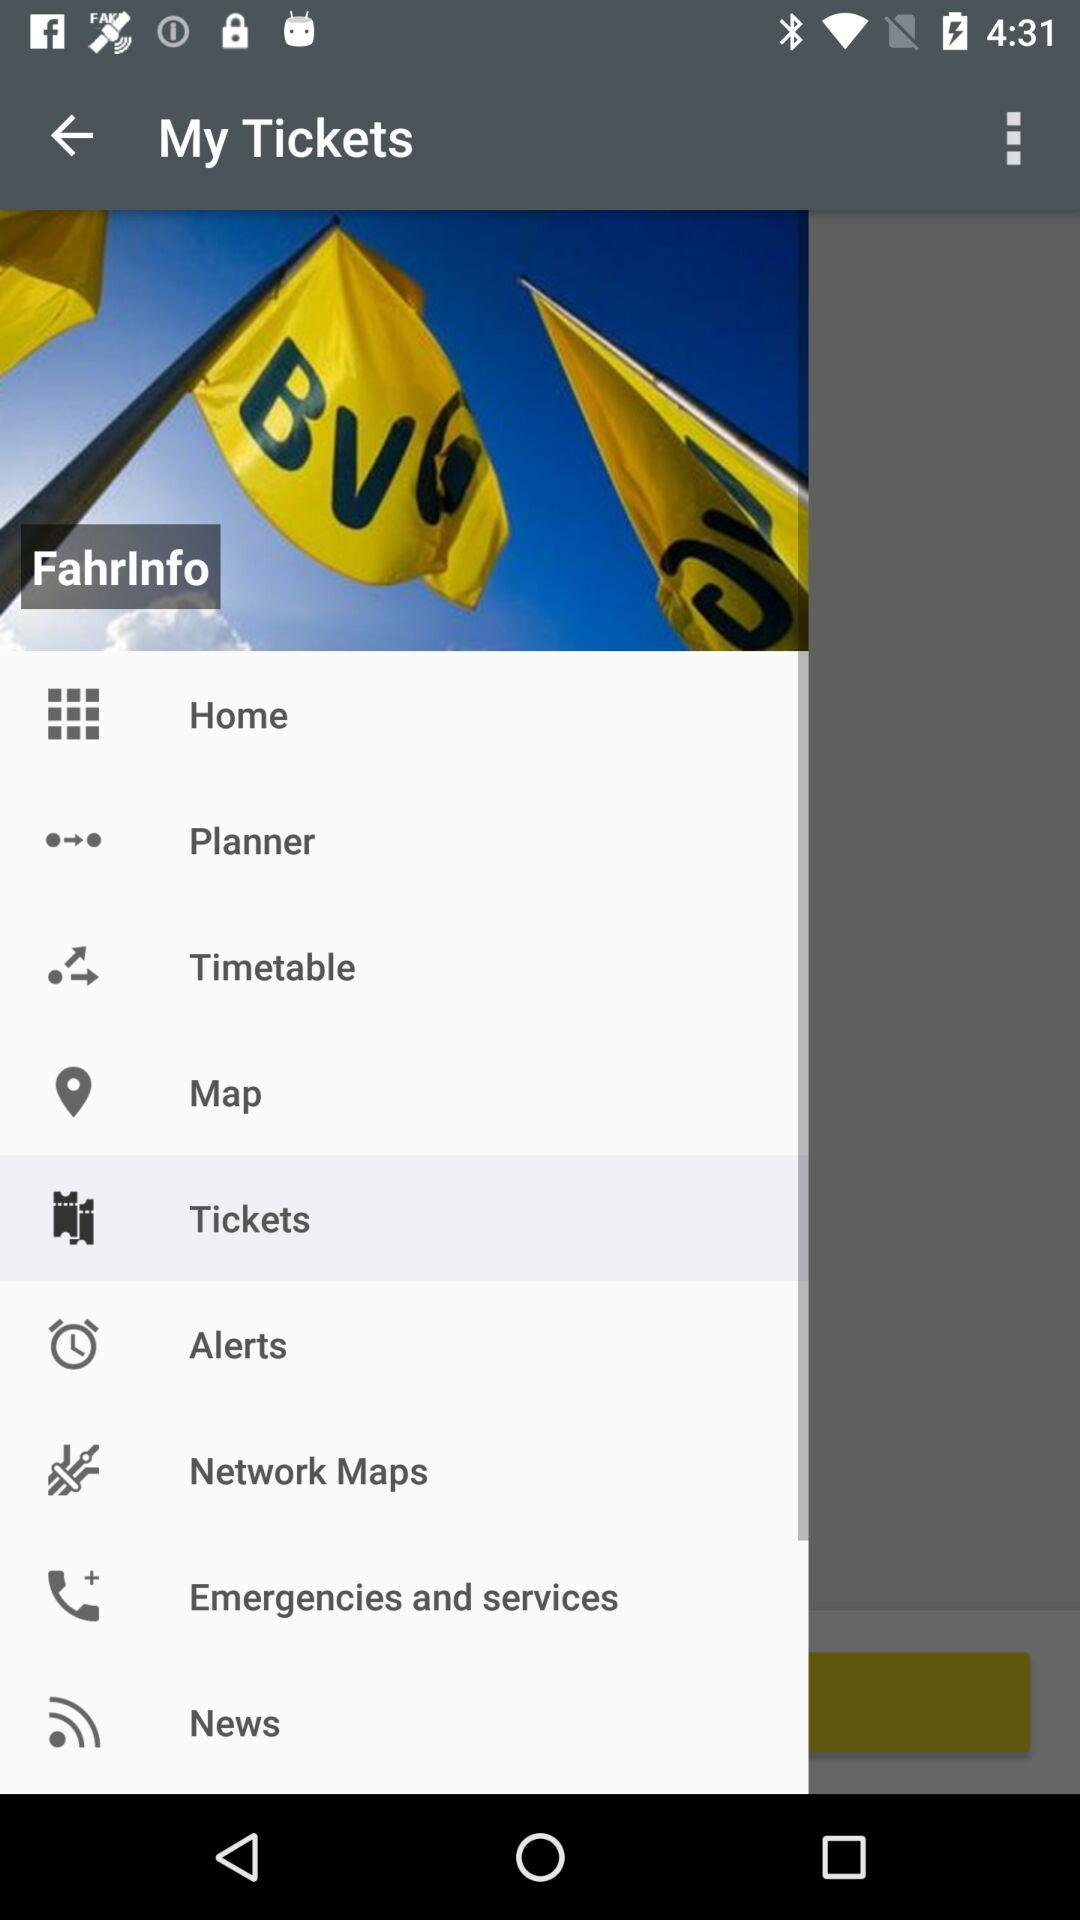What is the application name?
When the provided information is insufficient, respond with <no answer>. <no answer> 